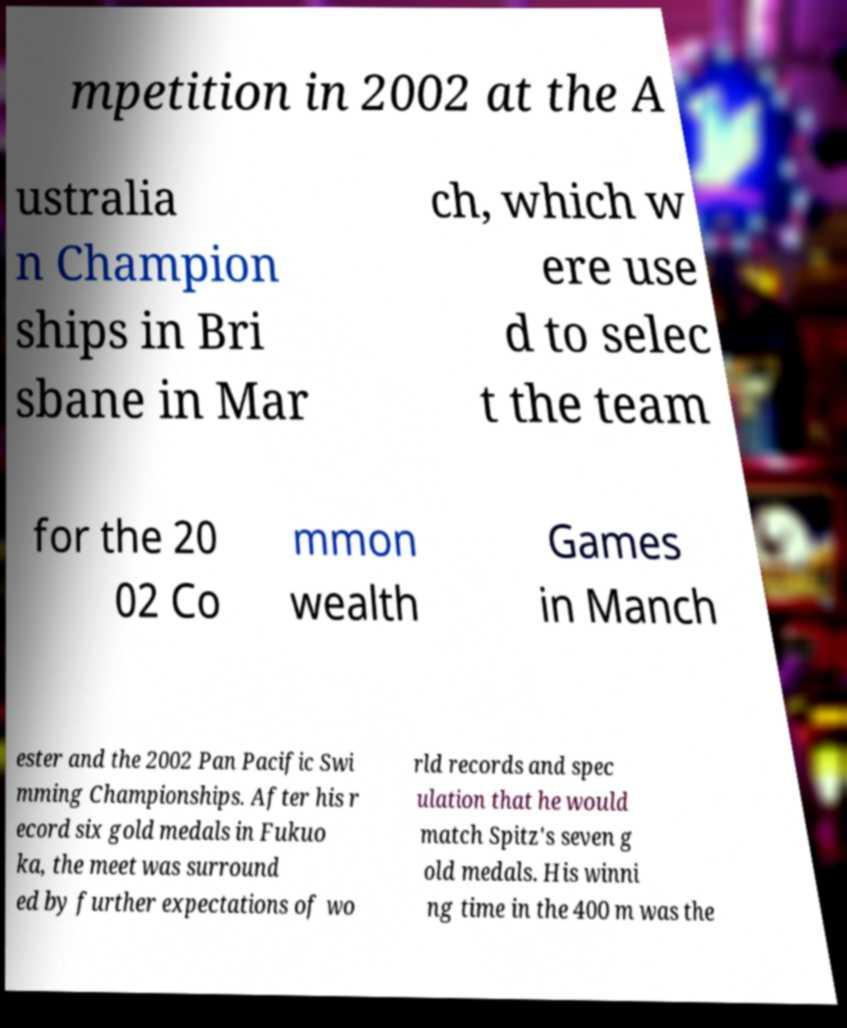There's text embedded in this image that I need extracted. Can you transcribe it verbatim? mpetition in 2002 at the A ustralia n Champion ships in Bri sbane in Mar ch, which w ere use d to selec t the team for the 20 02 Co mmon wealth Games in Manch ester and the 2002 Pan Pacific Swi mming Championships. After his r ecord six gold medals in Fukuo ka, the meet was surround ed by further expectations of wo rld records and spec ulation that he would match Spitz's seven g old medals. His winni ng time in the 400 m was the 